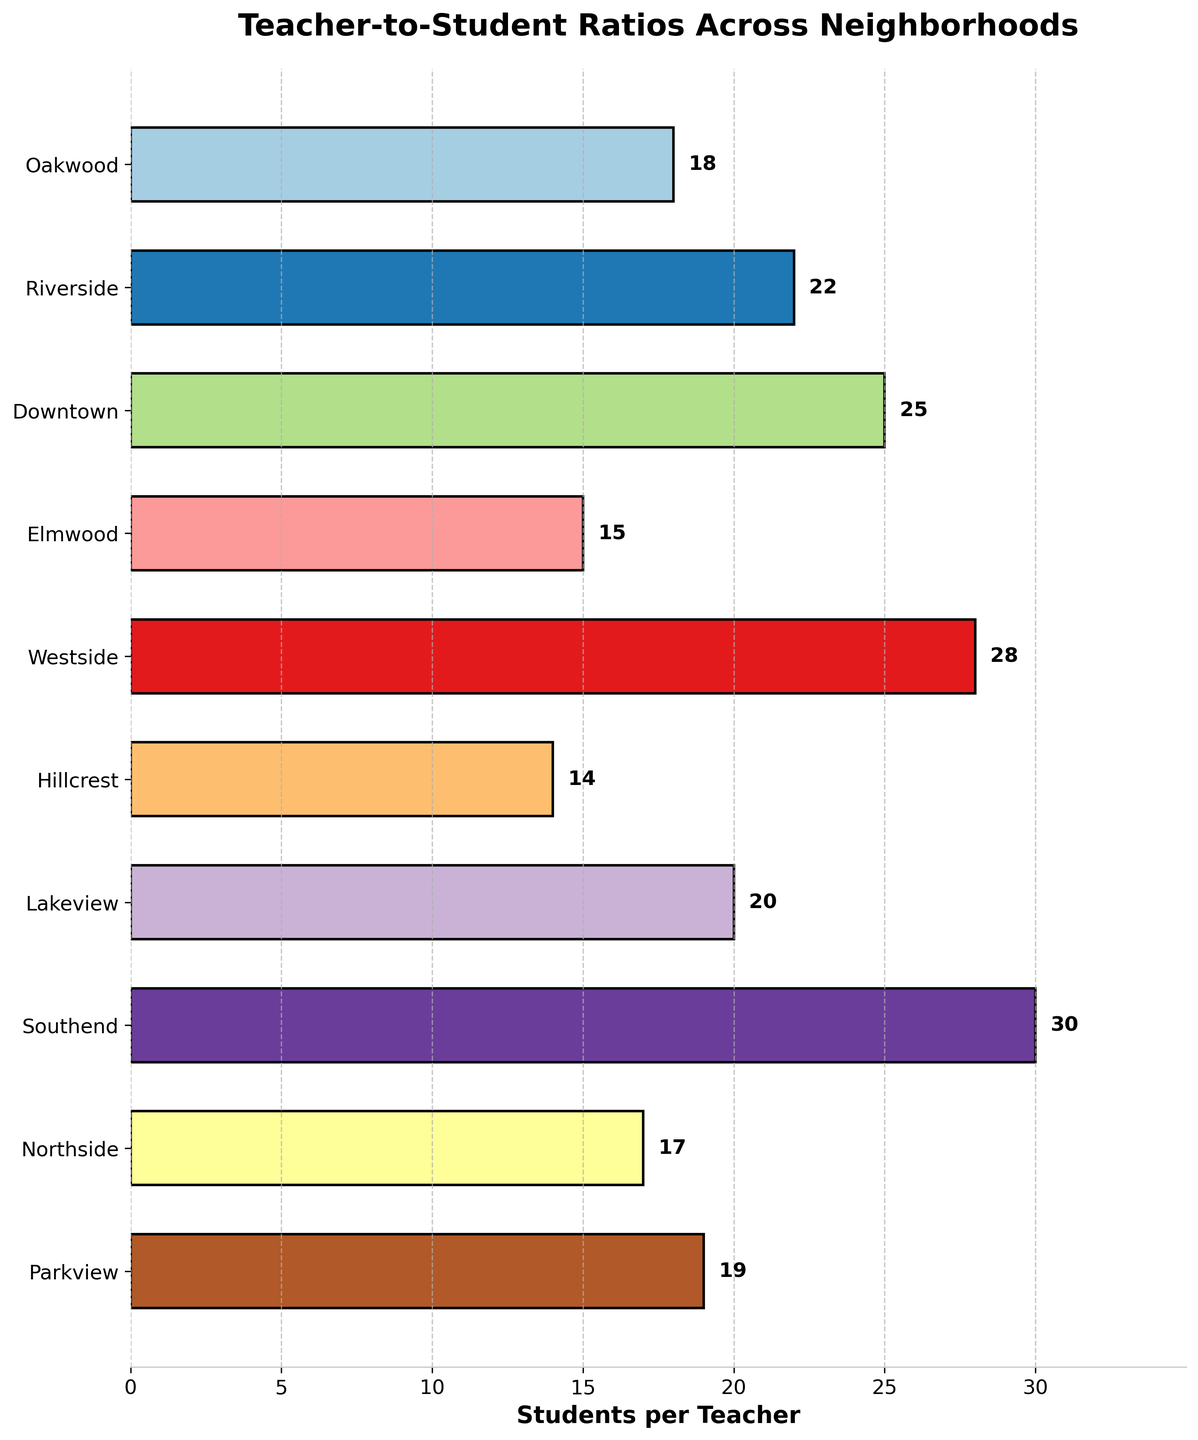Which neighborhood has the highest teacher-to-student ratio? Look at the bar representing the highest number of students per teacher. The tallest bar indicates Westside with a ratio of 1:28.
Answer: Westside What's the range of teacher-to-student ratios across the neighborhoods? To find the range, determine the highest and lowest values and subtract them. The highest ratio is 30 (Southend), and the lowest is 14 (Hillcrest). Subtract 14 from 30.
Answer: 16 Which neighborhoods have a teacher-to-student ratio of 1:20 or better? Identify the bars equal to or less than 20. The neighborhoods are Oakwood, Elmwood, Hillcrest, Northside, and Parkview.
Answer: Oakwood, Elmwood, Hillcrest, Northside, Parkview What's the average teacher-to-student ratio across all neighborhoods? Sum all the ratios (18+22+25+15+28+14+20+30+17+19) and divide by the number of neighborhoods (10). The sum is 208, so the average is 208/10.
Answer: 20.8 How does the teacher-to-student ratio in Downtown compare to Elmwood? Look at the bars for Downtown and Elmwood. Downtown has a ratio of 25, while Elmwood has 15. Downtown's ratio is higher by 10.
Answer: Downtown's is higher What is the median teacher-to-student ratio? Arrange the ratios in order: 14, 15, 17, 18, 19, 20, 22, 25, 28, 30. The median is the middle value or the average of the two middle values. The middle two values are 19 and 20.
Answer: 19.5 Which neighborhood has a ratio closest to the average ratio? The average ratio is 20.8. Compare each ratio to find the closest. Lakeview has a ratio of 20, making it the closest to the average.
Answer: Lakeview Is the teacher-to-student ratio at Parkview closer to Northside or Hillcrest? Parkview has 19, Northside has 17, and Hillcrest has 14. Calculate the differences: 19-17 = 2 and 19-14 = 5.
Answer: Northside How many neighborhoods have a teacher-to-student ratio greater than 1:25? Count the bars that have ratios higher than 25. The neighborhoods are Downtown, Westside, and Southend.
Answer: 3 Does Riverside have a higher teacher-to-student ratio than Oakwood and Northside? Riverside has a ratio of 22. Oakwood has 18, and Northside has 17. Since 22 is greater than both 18 and 17, Riverside has a higher ratio.
Answer: Yes 